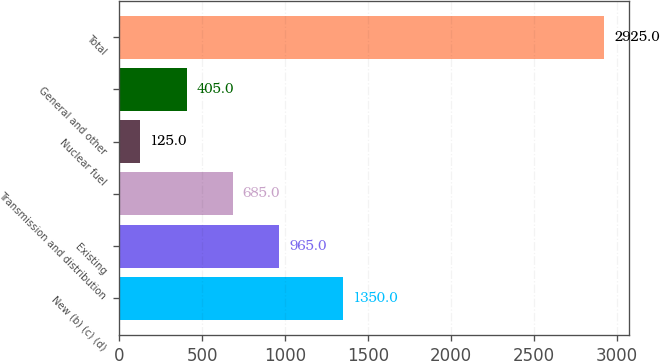<chart> <loc_0><loc_0><loc_500><loc_500><bar_chart><fcel>New (b) (c) (d)<fcel>Existing<fcel>Transmission and distribution<fcel>Nuclear fuel<fcel>General and other<fcel>Total<nl><fcel>1350<fcel>965<fcel>685<fcel>125<fcel>405<fcel>2925<nl></chart> 